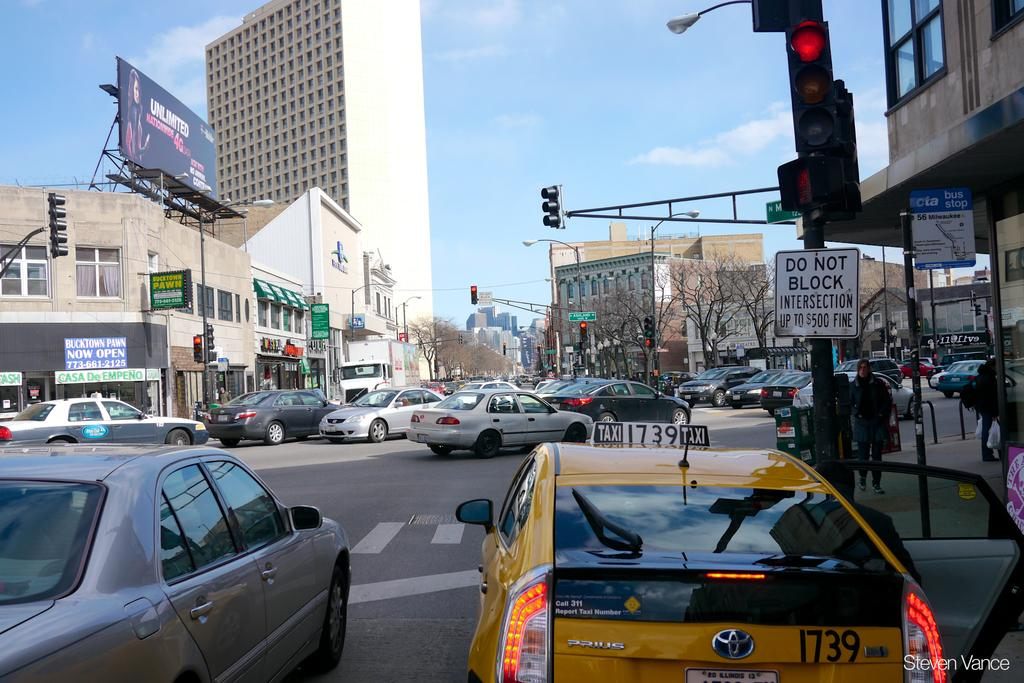Provide a one-sentence caption for the provided image. Busy street with a square white sign that has black letters Do Not Block Intersection up to $500 fine. 